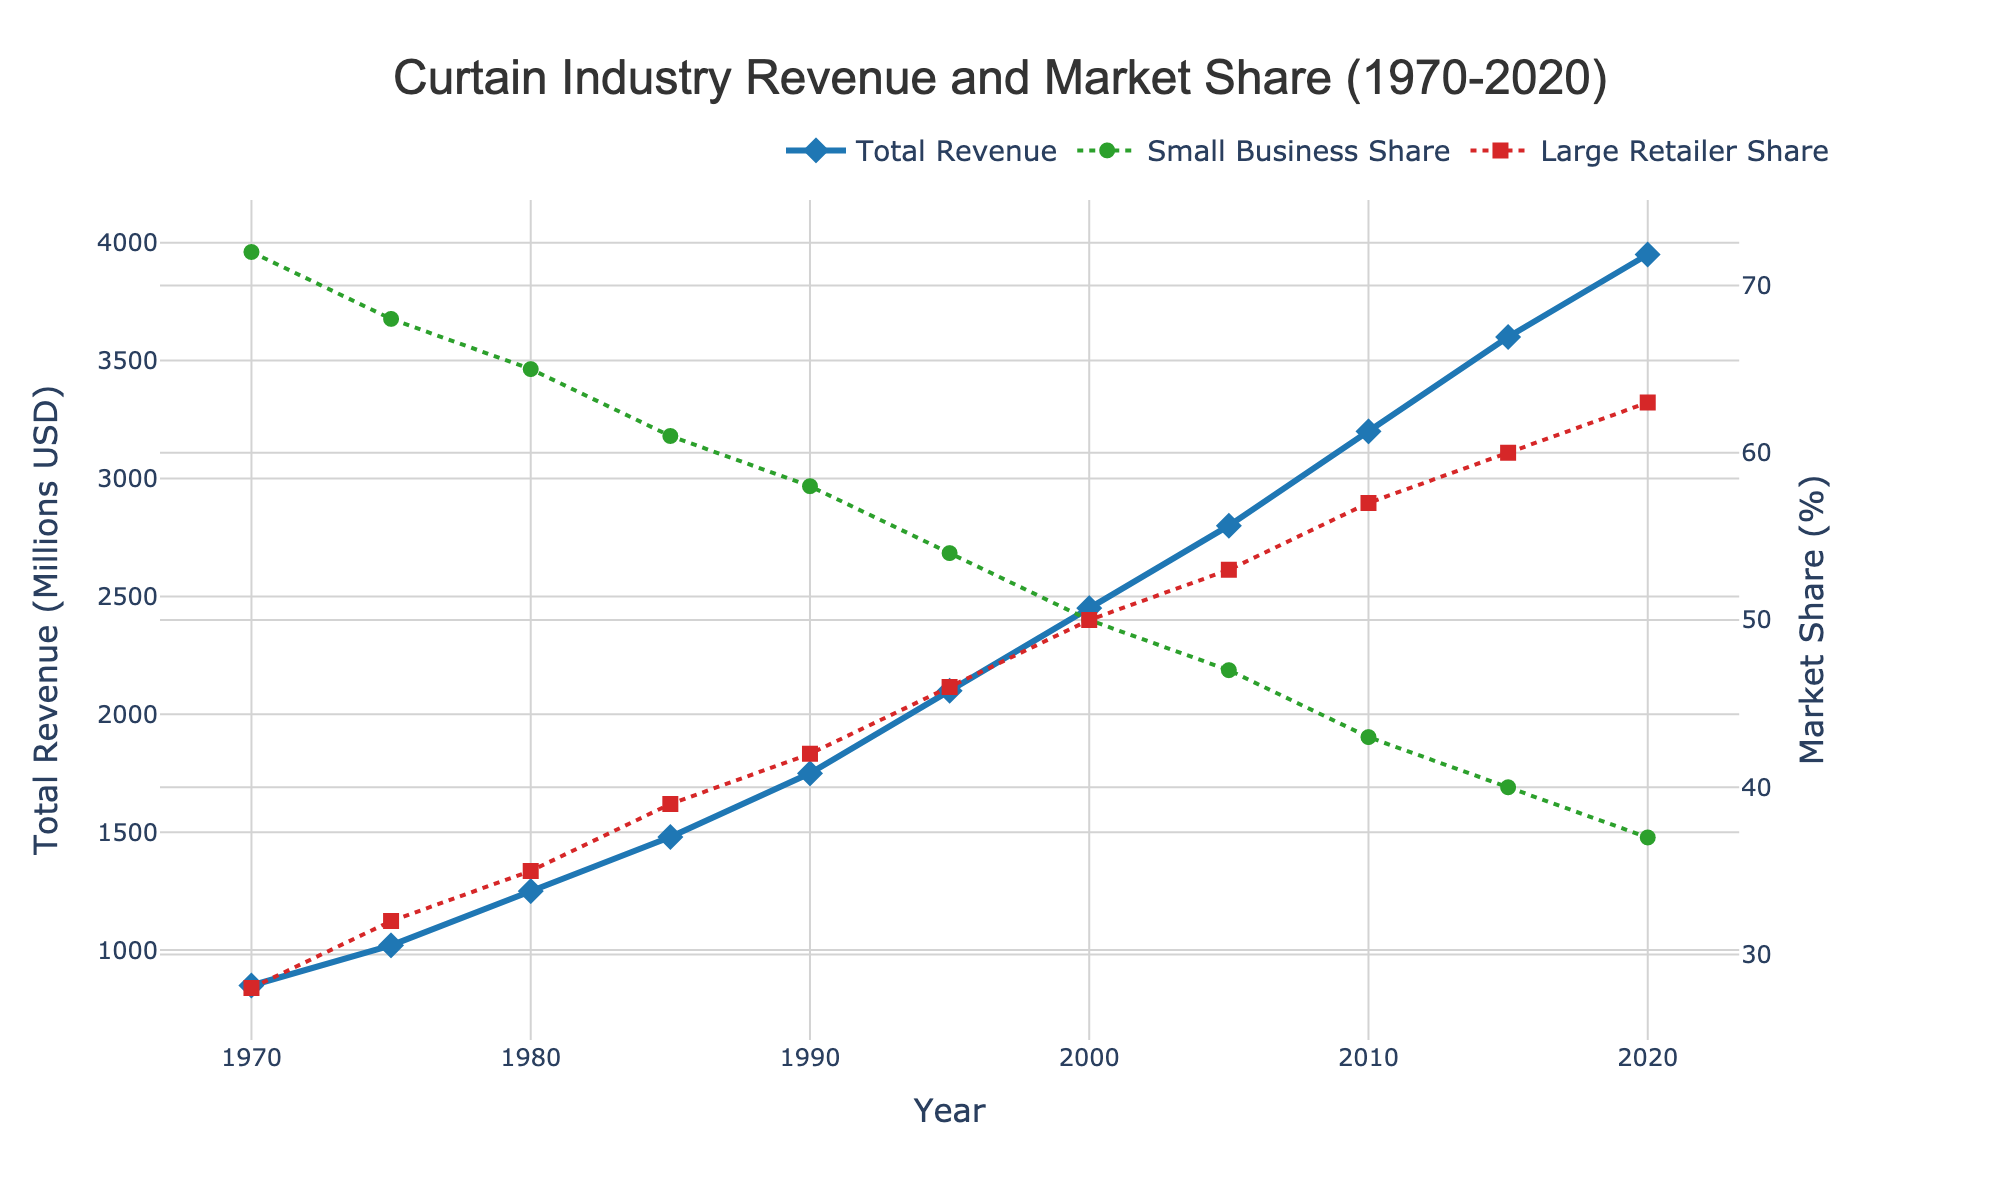How has the total revenue of the curtain industry changed from 1970 to 2020? By looking at the line representing total revenue, we see that it has increased from 850 million USD in 1970 to 3950 million USD in 2020. The change in revenue is 3950 - 850 = 3100 million USD.
Answer: Increased by 3100 million USD What was the market share difference between small businesses and large retailers in 1990? By looking at the lines for the small business and large retailer market shares in 1990, we see that the market share for small businesses was 58% and for large retailers, it was 42%. The difference is 58% - 42% = 16%.
Answer: 16% In what year did large retailers surpass a 50% market share? By looking at the 'Large Retailer Share' line, we see that it crossed the 50% mark between 2000 and 2005. Specifically, in 2005, it surpassed 50% with a value of 53%.
Answer: 2005 What was the trend in small business market share from 1970 to 2020? The line for small business market share shows a decreasing trend over the years. It starts at 72% in 1970 and steadily decreases to 37% in 2020.
Answer: Decreasing Compare the total revenue in 1980 and 2010. By how much did it increase? In 1980, the total revenue was 1250 million USD and in 2010 it was 3200 million USD. The increase is 3200 - 1250 = 1950 million USD.
Answer: 1950 million USD Which year had the highest small business market share? By looking at the 'Small Business Share' line, we see that the highest value is in 1970 with 72%.
Answer: 1970 What is the average total revenue for the years 1970, 1980, and 1990? The total revenues for the years are 850, 1250, and 1750 million USD respectively. The average is (850 + 1250 + 1750) / 3 = 1283.33 million USD.
Answer: 1283.33 million USD By how much did the total revenue of the curtain industry decrease or increase from 2000 to 2015? The total revenue in 2000 was 2450 million USD and in 2015 it was 3600 million USD. The increase is 3600 - 2450 = 1150 million USD.
Answer: Increased by 1150 million USD When did the market share of small businesses drop below 50%? The 'Small Business Share' line drops below 50% between 1995 and 2000. Specifically, in 2000, it reached 50%, so it dropped below 50% after that.
Answer: 2000 Which market share shows a consistently increasing trend over the years? The 'Large Retailer Share' line shows a consistently increasing trend from 1970 to 2020, growing from 28% to 63%.
Answer: Large retailer market share 